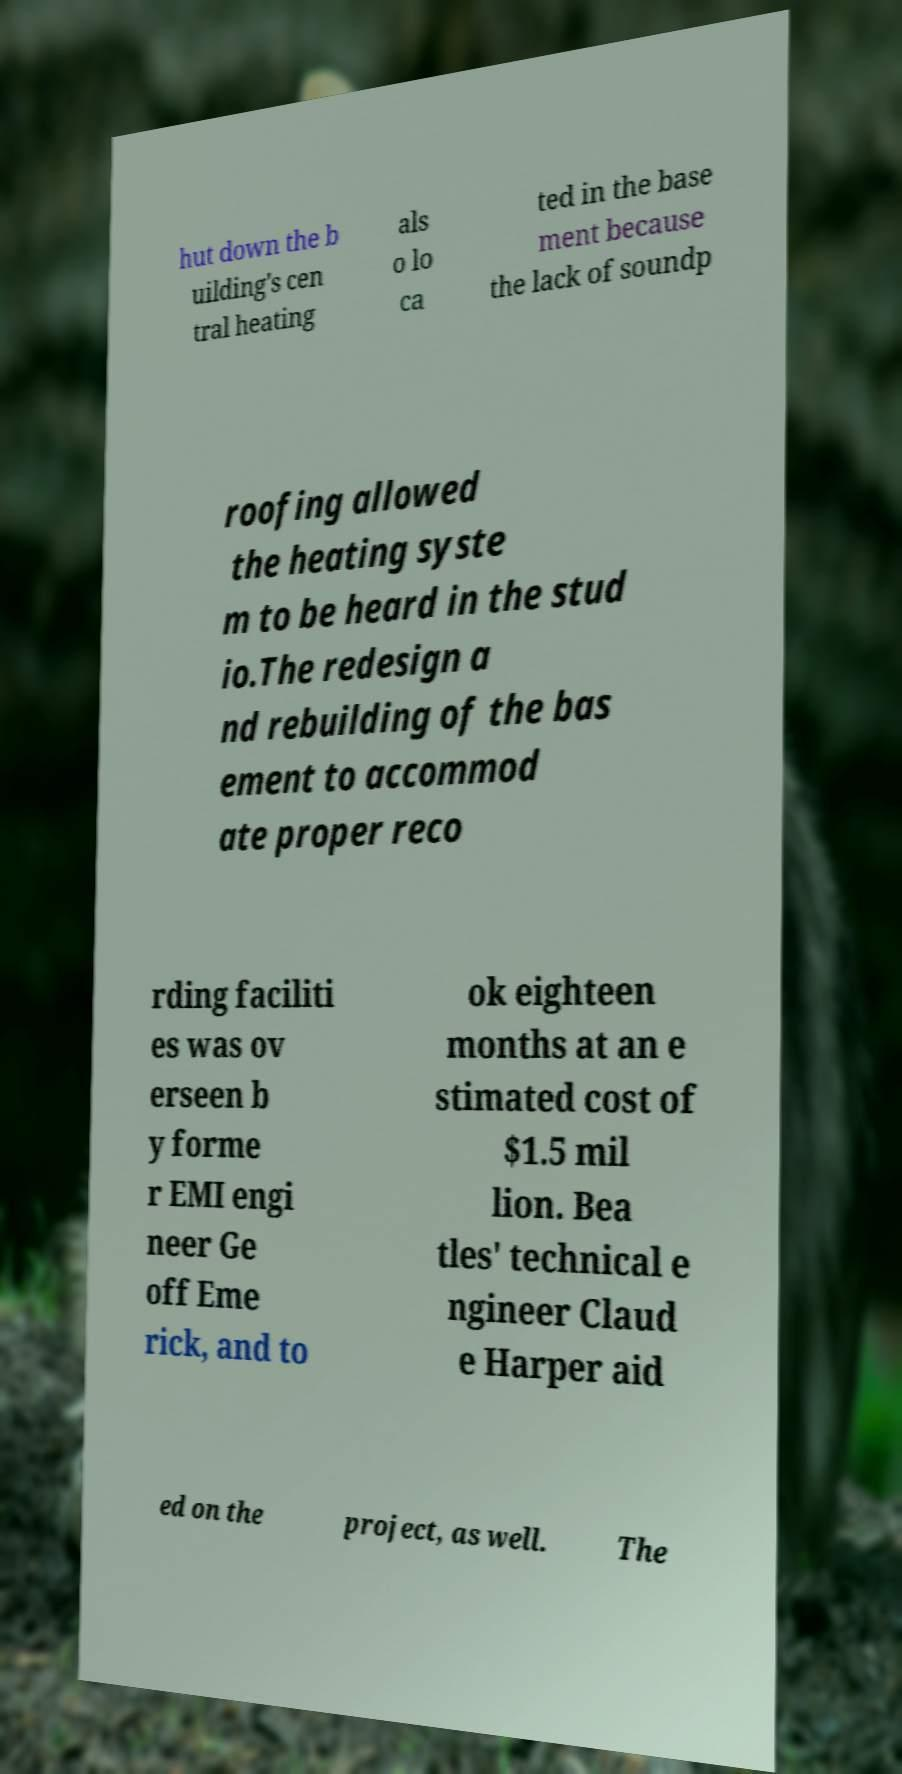Could you assist in decoding the text presented in this image and type it out clearly? hut down the b uilding's cen tral heating als o lo ca ted in the base ment because the lack of soundp roofing allowed the heating syste m to be heard in the stud io.The redesign a nd rebuilding of the bas ement to accommod ate proper reco rding faciliti es was ov erseen b y forme r EMI engi neer Ge off Eme rick, and to ok eighteen months at an e stimated cost of $1.5 mil lion. Bea tles' technical e ngineer Claud e Harper aid ed on the project, as well. The 